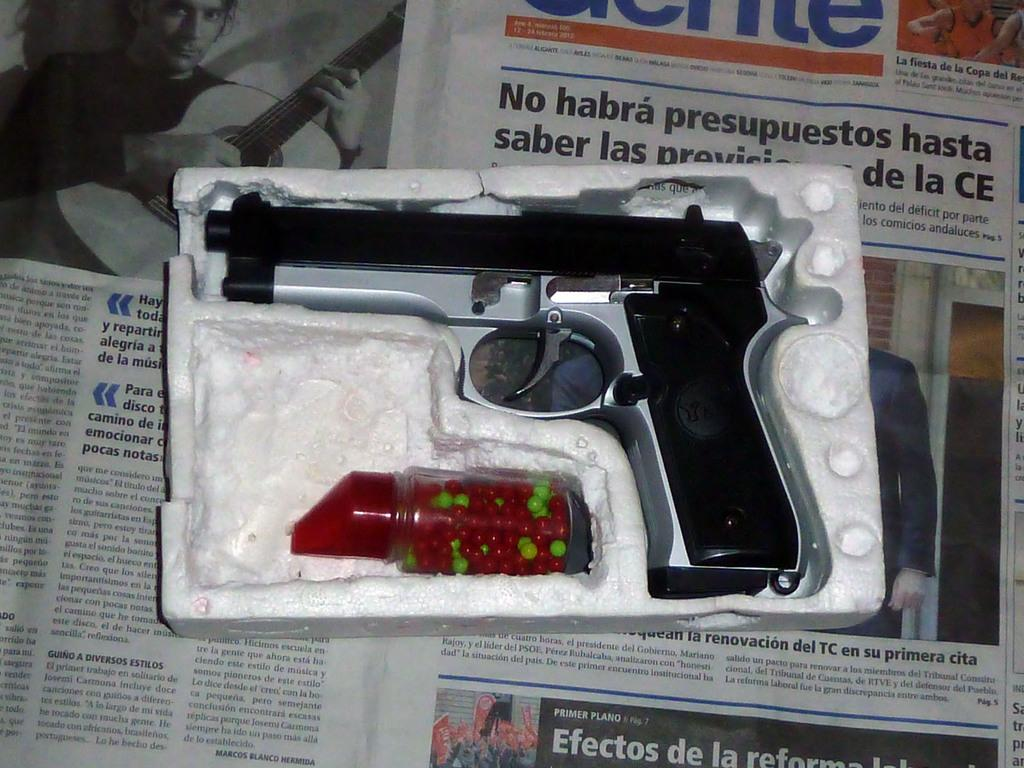What type of weapon is present in the image? There is a gun in the image. What ammunition is associated with the gun in the image? There are bullets in a bottle in the image. What type of reading material is present in the image? There is a newspaper in the image. What type of boundary is depicted in the image? There is no boundary depicted in the image; it features a gun, bullets, and a newspaper. 